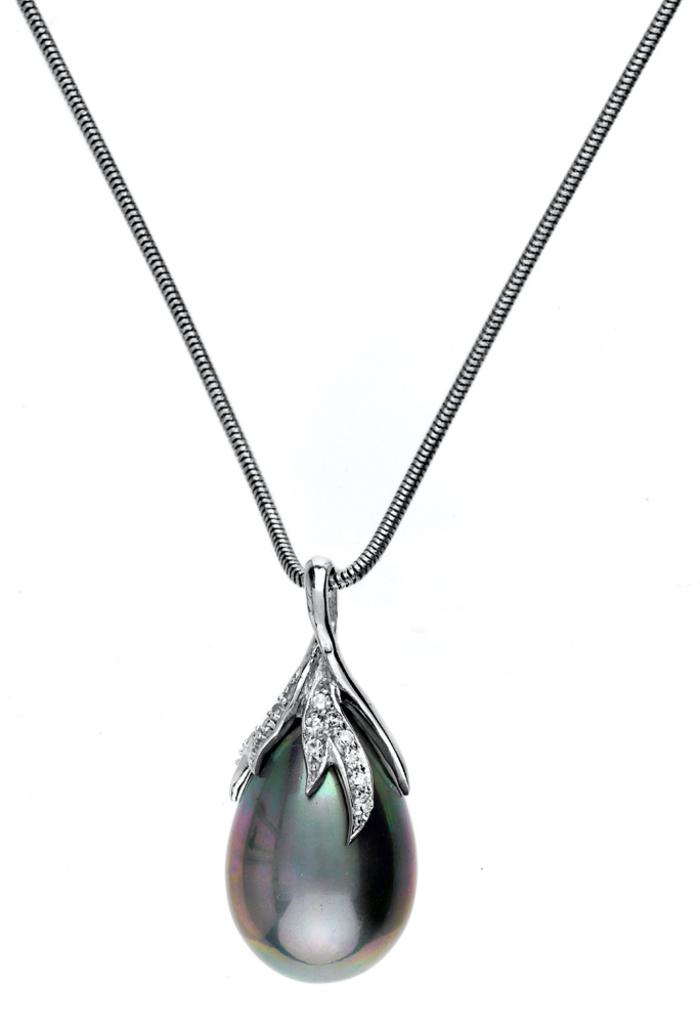What is the main object in the image? There is a locket in the image. How is the locket connected to the chain? The locket is attached to a chain. What color is the background of the image? The background of the image is white. What type of club does the farmer use to harvest crops in the image? There is no farmer or club present in the image; it features a locket attached to a chain with a white background. 